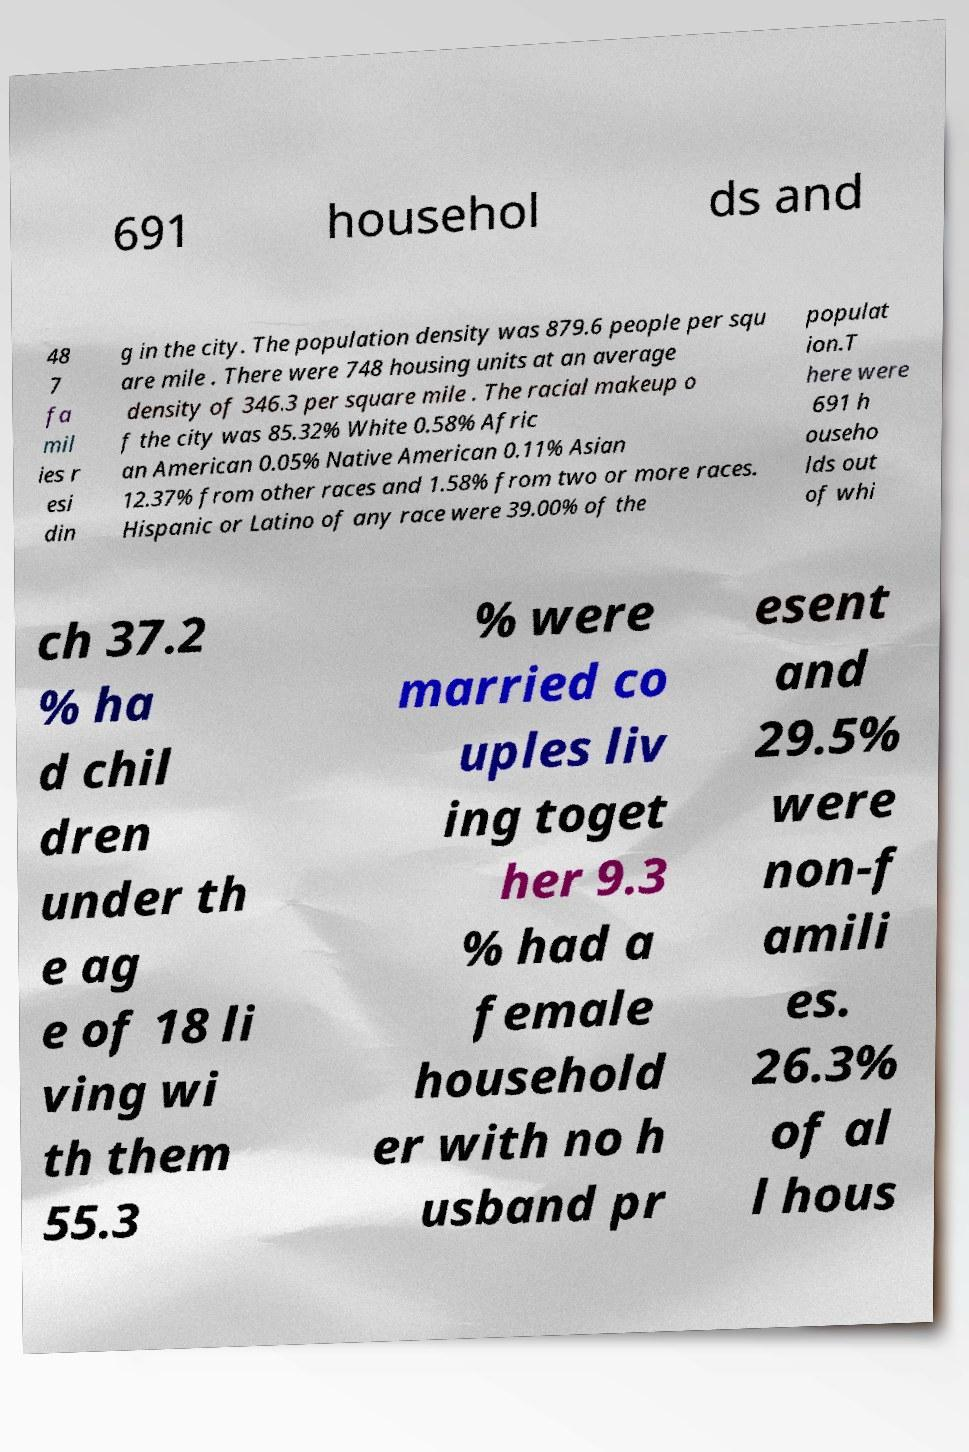Could you extract and type out the text from this image? 691 househol ds and 48 7 fa mil ies r esi din g in the city. The population density was 879.6 people per squ are mile . There were 748 housing units at an average density of 346.3 per square mile . The racial makeup o f the city was 85.32% White 0.58% Afric an American 0.05% Native American 0.11% Asian 12.37% from other races and 1.58% from two or more races. Hispanic or Latino of any race were 39.00% of the populat ion.T here were 691 h ouseho lds out of whi ch 37.2 % ha d chil dren under th e ag e of 18 li ving wi th them 55.3 % were married co uples liv ing toget her 9.3 % had a female household er with no h usband pr esent and 29.5% were non-f amili es. 26.3% of al l hous 